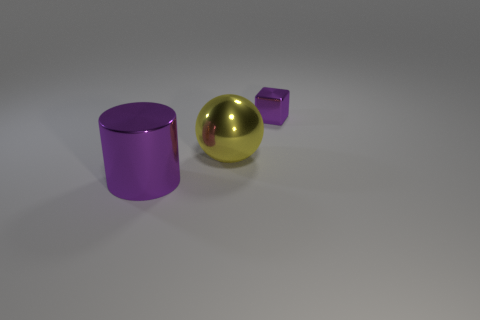What number of objects are purple metallic things to the left of the large ball or big blue metallic cylinders?
Ensure brevity in your answer.  1. Do the purple cube and the large cylinder have the same material?
Ensure brevity in your answer.  Yes. Is the shape of the purple thing that is on the left side of the tiny shiny object the same as the shiny thing on the right side of the big yellow object?
Keep it short and to the point. No. Does the block have the same size as the purple object that is in front of the metallic sphere?
Give a very brief answer. No. What number of other objects are the same material as the yellow sphere?
Provide a succinct answer. 2. Are there any other things that are the same shape as the small thing?
Give a very brief answer. No. What color is the large object behind the purple metal object that is on the left side of the tiny purple shiny cube behind the yellow metal object?
Provide a succinct answer. Yellow. There is a metal object that is both right of the big purple shiny object and in front of the small block; what shape is it?
Your answer should be very brief. Sphere. Is there anything else that is the same size as the metal cylinder?
Offer a terse response. Yes. What is the color of the large shiny object that is behind the thing that is in front of the large ball?
Offer a very short reply. Yellow. 